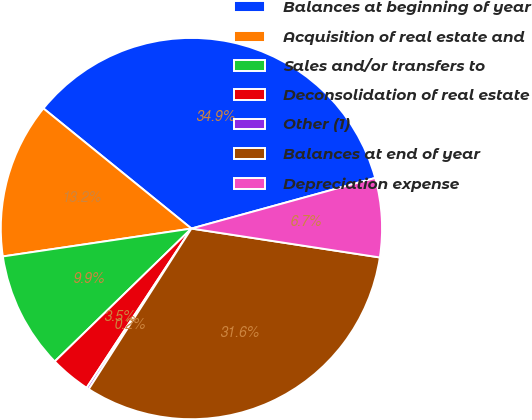<chart> <loc_0><loc_0><loc_500><loc_500><pie_chart><fcel>Balances at beginning of year<fcel>Acquisition of real estate and<fcel>Sales and/or transfers to<fcel>Deconsolidation of real estate<fcel>Other (1)<fcel>Balances at end of year<fcel>Depreciation expense<nl><fcel>34.87%<fcel>13.19%<fcel>9.94%<fcel>3.46%<fcel>0.21%<fcel>31.63%<fcel>6.7%<nl></chart> 